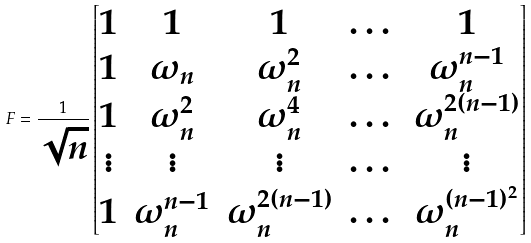Convert formula to latex. <formula><loc_0><loc_0><loc_500><loc_500>F = \frac { 1 } { \sqrt { n } } \begin{bmatrix} 1 & 1 & 1 & \dots & 1 \\ 1 & \omega _ { n } & \omega _ { n } ^ { 2 } & \dots & \omega _ { n } ^ { n - 1 } \\ 1 & \omega _ { n } ^ { 2 } & \omega _ { n } ^ { 4 } & \dots & \omega _ { n } ^ { 2 ( n - 1 ) } \\ \vdots & \vdots & \vdots & \dots & \vdots \\ 1 & \omega _ { n } ^ { n - 1 } & \omega _ { n } ^ { 2 ( n - 1 ) } & \dots & \omega _ { n } ^ { ( n - 1 ) ^ { 2 } } \end{bmatrix}</formula> 